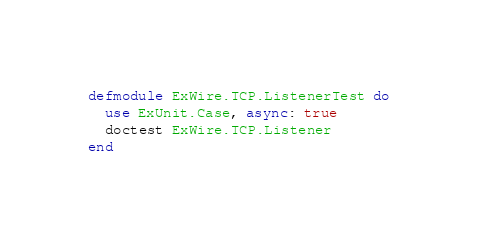<code> <loc_0><loc_0><loc_500><loc_500><_Elixir_>defmodule ExWire.TCP.ListenerTest do
  use ExUnit.Case, async: true
  doctest ExWire.TCP.Listener
end
</code> 